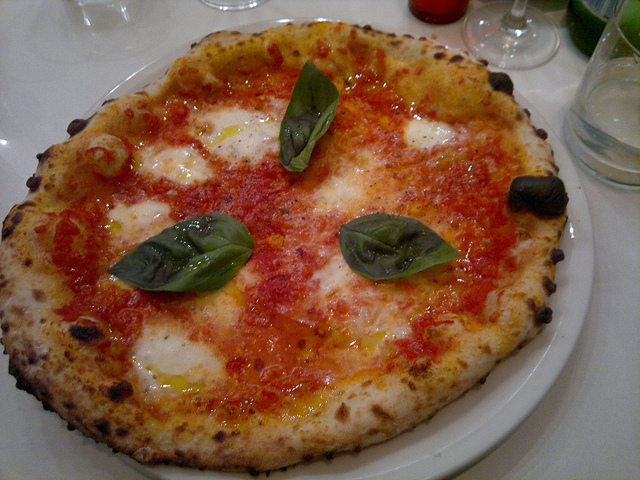<image>Is the pizza sauce organic? I don't know if the pizza sauce is organic. Is the pizza sauce organic? It is unknown if the pizza sauce is organic. 